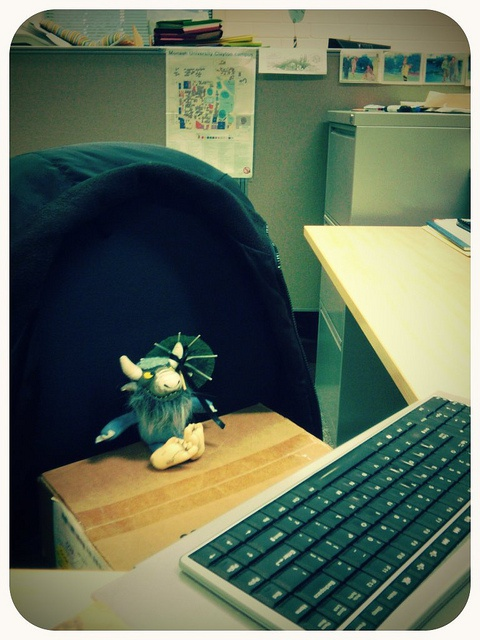Describe the objects in this image and their specific colors. I can see chair in white, black, and teal tones, keyboard in white, teal, black, darkgreen, and gray tones, book in white, beige, and teal tones, book in white, black, gray, and brown tones, and book in white, black, tan, maroon, and brown tones in this image. 